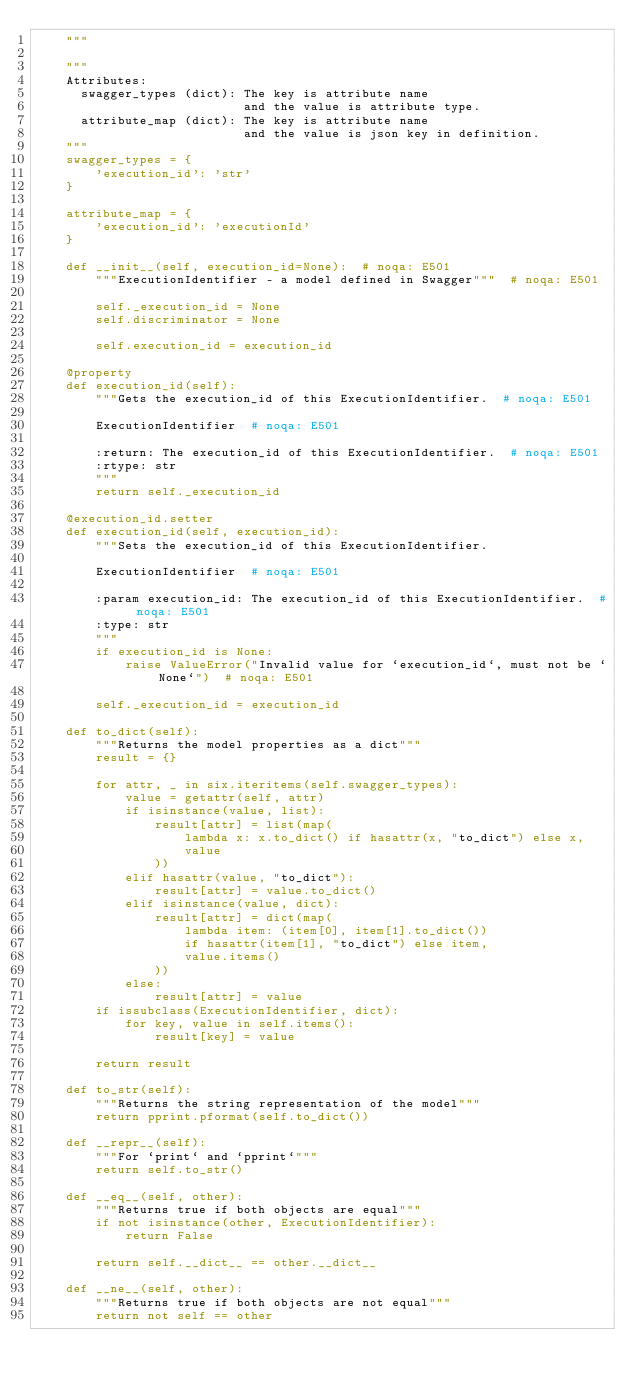Convert code to text. <code><loc_0><loc_0><loc_500><loc_500><_Python_>    """

    """
    Attributes:
      swagger_types (dict): The key is attribute name
                            and the value is attribute type.
      attribute_map (dict): The key is attribute name
                            and the value is json key in definition.
    """
    swagger_types = {
        'execution_id': 'str'
    }

    attribute_map = {
        'execution_id': 'executionId'
    }

    def __init__(self, execution_id=None):  # noqa: E501
        """ExecutionIdentifier - a model defined in Swagger"""  # noqa: E501

        self._execution_id = None
        self.discriminator = None

        self.execution_id = execution_id

    @property
    def execution_id(self):
        """Gets the execution_id of this ExecutionIdentifier.  # noqa: E501

        ExecutionIdentifier  # noqa: E501

        :return: The execution_id of this ExecutionIdentifier.  # noqa: E501
        :rtype: str
        """
        return self._execution_id

    @execution_id.setter
    def execution_id(self, execution_id):
        """Sets the execution_id of this ExecutionIdentifier.

        ExecutionIdentifier  # noqa: E501

        :param execution_id: The execution_id of this ExecutionIdentifier.  # noqa: E501
        :type: str
        """
        if execution_id is None:
            raise ValueError("Invalid value for `execution_id`, must not be `None`")  # noqa: E501

        self._execution_id = execution_id

    def to_dict(self):
        """Returns the model properties as a dict"""
        result = {}

        for attr, _ in six.iteritems(self.swagger_types):
            value = getattr(self, attr)
            if isinstance(value, list):
                result[attr] = list(map(
                    lambda x: x.to_dict() if hasattr(x, "to_dict") else x,
                    value
                ))
            elif hasattr(value, "to_dict"):
                result[attr] = value.to_dict()
            elif isinstance(value, dict):
                result[attr] = dict(map(
                    lambda item: (item[0], item[1].to_dict())
                    if hasattr(item[1], "to_dict") else item,
                    value.items()
                ))
            else:
                result[attr] = value
        if issubclass(ExecutionIdentifier, dict):
            for key, value in self.items():
                result[key] = value

        return result

    def to_str(self):
        """Returns the string representation of the model"""
        return pprint.pformat(self.to_dict())

    def __repr__(self):
        """For `print` and `pprint`"""
        return self.to_str()

    def __eq__(self, other):
        """Returns true if both objects are equal"""
        if not isinstance(other, ExecutionIdentifier):
            return False

        return self.__dict__ == other.__dict__

    def __ne__(self, other):
        """Returns true if both objects are not equal"""
        return not self == other
</code> 